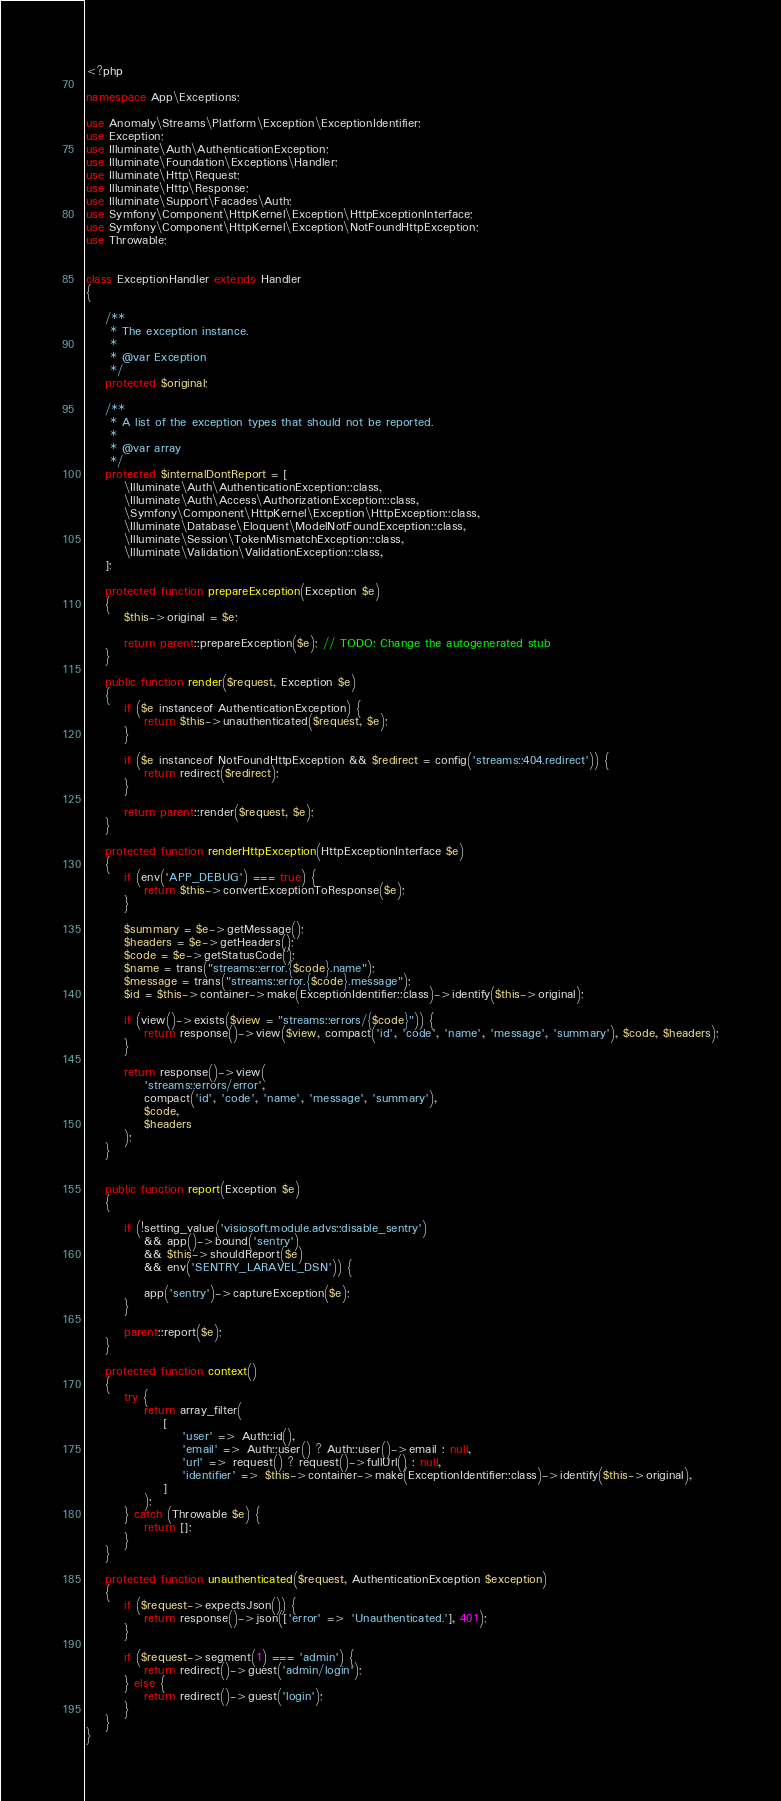Convert code to text. <code><loc_0><loc_0><loc_500><loc_500><_PHP_><?php

namespace App\Exceptions;

use Anomaly\Streams\Platform\Exception\ExceptionIdentifier;
use Exception;
use Illuminate\Auth\AuthenticationException;
use Illuminate\Foundation\Exceptions\Handler;
use Illuminate\Http\Request;
use Illuminate\Http\Response;
use Illuminate\Support\Facades\Auth;
use Symfony\Component\HttpKernel\Exception\HttpExceptionInterface;
use Symfony\Component\HttpKernel\Exception\NotFoundHttpException;
use Throwable;


class ExceptionHandler extends Handler
{

    /**
     * The exception instance.
     *
     * @var Exception
     */
    protected $original;

    /**
     * A list of the exception types that should not be reported.
     *
     * @var array
     */
    protected $internalDontReport = [
        \Illuminate\Auth\AuthenticationException::class,
        \Illuminate\Auth\Access\AuthorizationException::class,
        \Symfony\Component\HttpKernel\Exception\HttpException::class,
        \Illuminate\Database\Eloquent\ModelNotFoundException::class,
        \Illuminate\Session\TokenMismatchException::class,
        \Illuminate\Validation\ValidationException::class,
    ];

    protected function prepareException(Exception $e)
    {
        $this->original = $e;

        return parent::prepareException($e); // TODO: Change the autogenerated stub
    }

    public function render($request, Exception $e)
    {
        if ($e instanceof AuthenticationException) {
            return $this->unauthenticated($request, $e);
        }

        if ($e instanceof NotFoundHttpException && $redirect = config('streams::404.redirect')) {
            return redirect($redirect);
        }

        return parent::render($request, $e);
    }

    protected function renderHttpException(HttpExceptionInterface $e)
    {
        if (env('APP_DEBUG') === true) {
            return $this->convertExceptionToResponse($e);
        }

        $summary = $e->getMessage();
        $headers = $e->getHeaders();
        $code = $e->getStatusCode();
        $name = trans("streams::error.{$code}.name");
        $message = trans("streams::error.{$code}.message");
        $id = $this->container->make(ExceptionIdentifier::class)->identify($this->original);

        if (view()->exists($view = "streams::errors/{$code}")) {
            return response()->view($view, compact('id', 'code', 'name', 'message', 'summary'), $code, $headers);
        }

        return response()->view(
            'streams::errors/error',
            compact('id', 'code', 'name', 'message', 'summary'),
            $code,
            $headers
        );
    }


    public function report(Exception $e)
    {

        if (!setting_value('visiosoft.module.advs::disable_sentry')
	        && app()->bound('sentry')
	        && $this->shouldReport($e)
	        && env('SENTRY_LARAVEL_DSN')) {

            app('sentry')->captureException($e);
        }

        parent::report($e);
    }

    protected function context()
    {
        try {
            return array_filter(
                [
                    'user' => Auth::id(),
                    'email' => Auth::user() ? Auth::user()->email : null,
                    'url' => request() ? request()->fullUrl() : null,
                    'identifier' => $this->container->make(ExceptionIdentifier::class)->identify($this->original),
                ]
            );
        } catch (Throwable $e) {
            return [];
        }
    }

    protected function unauthenticated($request, AuthenticationException $exception)
    {
        if ($request->expectsJson()) {
            return response()->json(['error' => 'Unauthenticated.'], 401);
        }

        if ($request->segment(1) === 'admin') {
            return redirect()->guest('admin/login');
        } else {
            return redirect()->guest('login');
        }
    }
}
</code> 